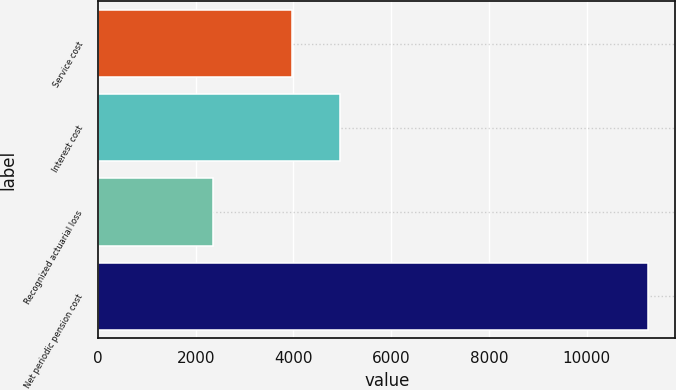Convert chart. <chart><loc_0><loc_0><loc_500><loc_500><bar_chart><fcel>Service cost<fcel>Interest cost<fcel>Recognized actuarial loss<fcel>Net periodic pension cost<nl><fcel>3971<fcel>4943<fcel>2343<fcel>11257<nl></chart> 